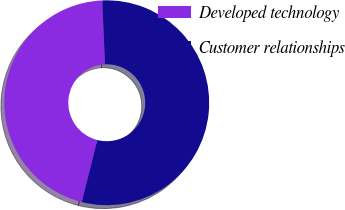<chart> <loc_0><loc_0><loc_500><loc_500><pie_chart><fcel>Developed technology<fcel>Customer relationships<nl><fcel>45.38%<fcel>54.62%<nl></chart> 